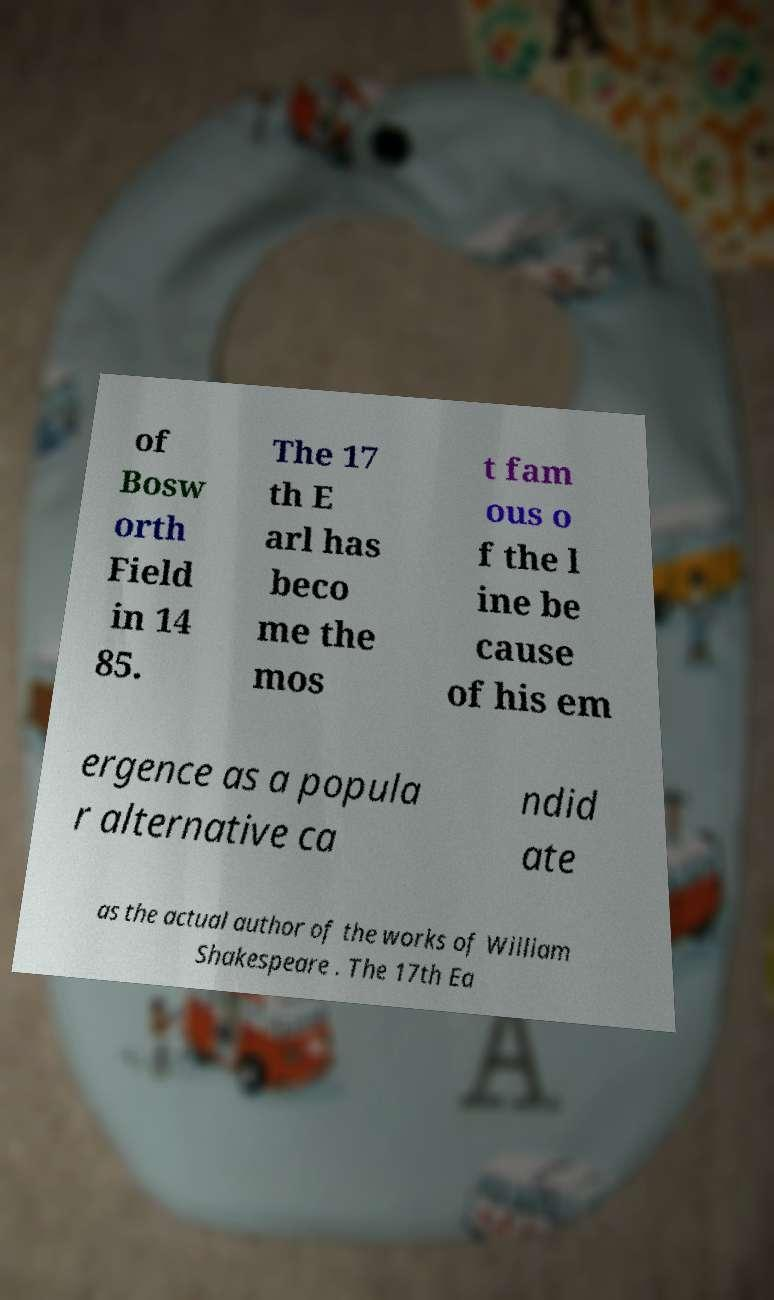Could you extract and type out the text from this image? of Bosw orth Field in 14 85. The 17 th E arl has beco me the mos t fam ous o f the l ine be cause of his em ergence as a popula r alternative ca ndid ate as the actual author of the works of William Shakespeare . The 17th Ea 